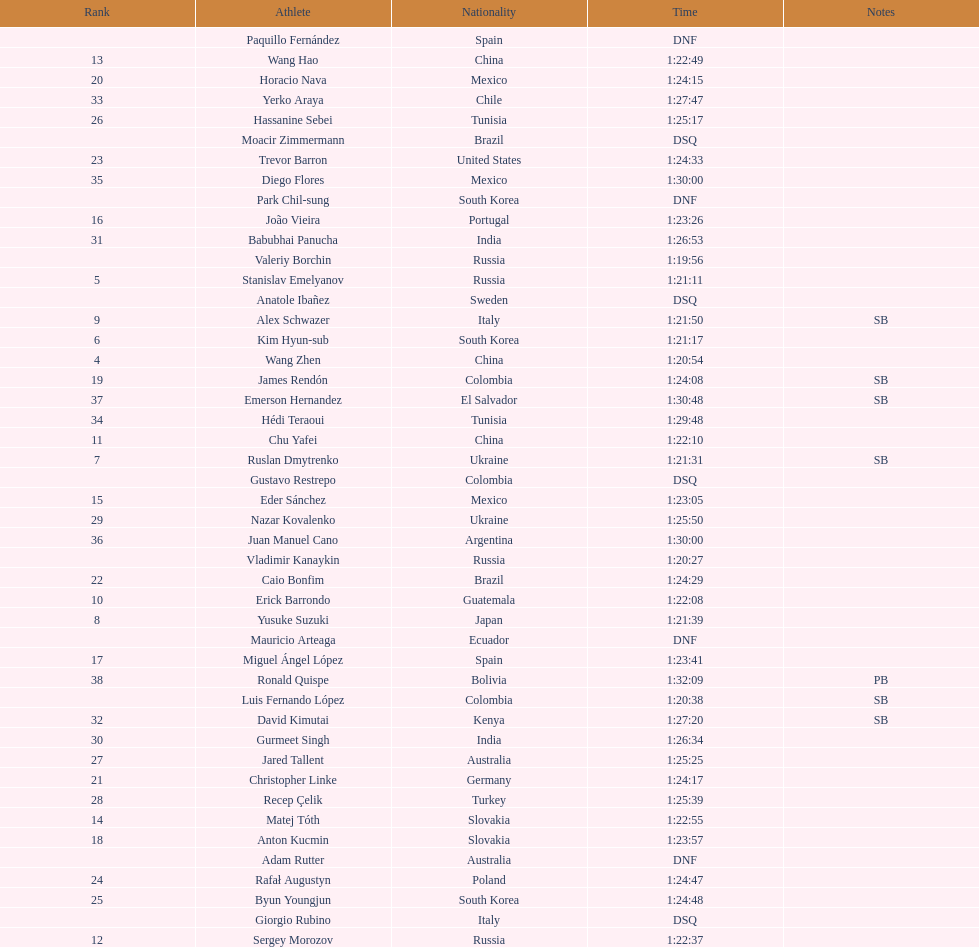Parse the table in full. {'header': ['Rank', 'Athlete', 'Nationality', 'Time', 'Notes'], 'rows': [['', 'Paquillo Fernández', 'Spain', 'DNF', ''], ['13', 'Wang Hao', 'China', '1:22:49', ''], ['20', 'Horacio Nava', 'Mexico', '1:24:15', ''], ['33', 'Yerko Araya', 'Chile', '1:27:47', ''], ['26', 'Hassanine Sebei', 'Tunisia', '1:25:17', ''], ['', 'Moacir Zimmermann', 'Brazil', 'DSQ', ''], ['23', 'Trevor Barron', 'United States', '1:24:33', ''], ['35', 'Diego Flores', 'Mexico', '1:30:00', ''], ['', 'Park Chil-sung', 'South Korea', 'DNF', ''], ['16', 'João Vieira', 'Portugal', '1:23:26', ''], ['31', 'Babubhai Panucha', 'India', '1:26:53', ''], ['', 'Valeriy Borchin', 'Russia', '1:19:56', ''], ['5', 'Stanislav Emelyanov', 'Russia', '1:21:11', ''], ['', 'Anatole Ibañez', 'Sweden', 'DSQ', ''], ['9', 'Alex Schwazer', 'Italy', '1:21:50', 'SB'], ['6', 'Kim Hyun-sub', 'South Korea', '1:21:17', ''], ['4', 'Wang Zhen', 'China', '1:20:54', ''], ['19', 'James Rendón', 'Colombia', '1:24:08', 'SB'], ['37', 'Emerson Hernandez', 'El Salvador', '1:30:48', 'SB'], ['34', 'Hédi Teraoui', 'Tunisia', '1:29:48', ''], ['11', 'Chu Yafei', 'China', '1:22:10', ''], ['7', 'Ruslan Dmytrenko', 'Ukraine', '1:21:31', 'SB'], ['', 'Gustavo Restrepo', 'Colombia', 'DSQ', ''], ['15', 'Eder Sánchez', 'Mexico', '1:23:05', ''], ['29', 'Nazar Kovalenko', 'Ukraine', '1:25:50', ''], ['36', 'Juan Manuel Cano', 'Argentina', '1:30:00', ''], ['', 'Vladimir Kanaykin', 'Russia', '1:20:27', ''], ['22', 'Caio Bonfim', 'Brazil', '1:24:29', ''], ['10', 'Erick Barrondo', 'Guatemala', '1:22:08', ''], ['8', 'Yusuke Suzuki', 'Japan', '1:21:39', ''], ['', 'Mauricio Arteaga', 'Ecuador', 'DNF', ''], ['17', 'Miguel Ángel López', 'Spain', '1:23:41', ''], ['38', 'Ronald Quispe', 'Bolivia', '1:32:09', 'PB'], ['', 'Luis Fernando López', 'Colombia', '1:20:38', 'SB'], ['32', 'David Kimutai', 'Kenya', '1:27:20', 'SB'], ['30', 'Gurmeet Singh', 'India', '1:26:34', ''], ['27', 'Jared Tallent', 'Australia', '1:25:25', ''], ['21', 'Christopher Linke', 'Germany', '1:24:17', ''], ['28', 'Recep Çelik', 'Turkey', '1:25:39', ''], ['14', 'Matej Tóth', 'Slovakia', '1:22:55', ''], ['18', 'Anton Kucmin', 'Slovakia', '1:23:57', ''], ['', 'Adam Rutter', 'Australia', 'DNF', ''], ['24', 'Rafał Augustyn', 'Poland', '1:24:47', ''], ['25', 'Byun Youngjun', 'South Korea', '1:24:48', ''], ['', 'Giorgio Rubino', 'Italy', 'DSQ', ''], ['12', 'Sergey Morozov', 'Russia', '1:22:37', '']]} How many competitors were from russia? 4. 